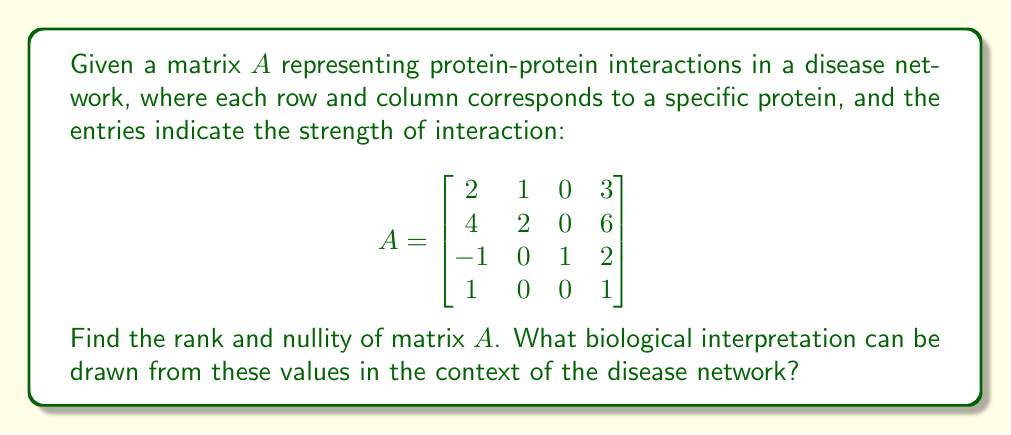Give your solution to this math problem. To find the rank and nullity of matrix $A$, we'll follow these steps:

1) First, we need to find the rank of the matrix. The rank is equal to the number of linearly independent rows or columns.

2) To determine this, we'll use Gaussian elimination to get the matrix in row echelon form:

   $$\begin{bmatrix}
   2 & 1 & 0 & 3 \\
   4 & 2 & 0 & 6 \\
   -1 & 0 & 1 & 2 \\
   1 & 0 & 0 & 1
   \end{bmatrix} \rightarrow
   \begin{bmatrix}
   2 & 1 & 0 & 3 \\
   0 & 0 & 0 & 0 \\
   0 & 1 & 1 & 5 \\
   0 & -\frac{1}{2} & 0 & -\frac{1}{2}
   \end{bmatrix}$$

3) The number of non-zero rows in the row echelon form is 3, so the rank of $A$ is 3.

4) The nullity of a matrix is defined as the dimension of its null space. It can be calculated using the formula:
   
   nullity = number of columns - rank

5) Matrix $A$ has 4 columns and rank 3, so:
   
   nullity = 4 - 3 = 1

6) Biological interpretation:
   - The rank (3) represents the number of linearly independent protein interactions in the network. This suggests that there are 3 key interaction patterns that describe the entire network.
   - The nullity (1) indicates that there is one degree of freedom in the network. This could represent a conserved or redundant interaction pattern across the network.
Answer: Rank = 3, Nullity = 1 